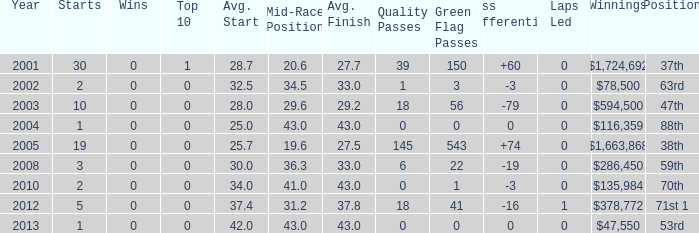How many starts for an average finish greater than 43? None. 